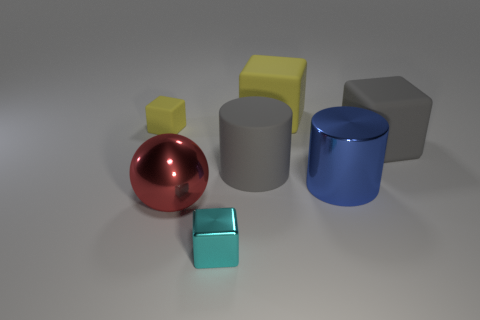How many other things are there of the same size as the blue shiny cylinder?
Provide a short and direct response. 4. Is the shape of the gray matte thing that is on the left side of the gray matte cube the same as  the small matte object?
Your answer should be very brief. No. What is the material of the other large object that is the same shape as the blue thing?
Give a very brief answer. Rubber. How many yellow rubber cubes have the same size as the metal cylinder?
Provide a short and direct response. 1. There is a object that is both behind the shiny cylinder and to the left of the tiny cyan object; what color is it?
Provide a succinct answer. Yellow. Is the number of rubber blocks less than the number of big red balls?
Provide a short and direct response. No. There is a big metal sphere; does it have the same color as the block that is to the right of the big blue thing?
Offer a terse response. No. Are there an equal number of red objects that are in front of the large gray matte block and gray objects in front of the big ball?
Your answer should be very brief. No. What number of gray rubber things are the same shape as the cyan metal thing?
Your answer should be very brief. 1. Are there any big things?
Keep it short and to the point. Yes. 